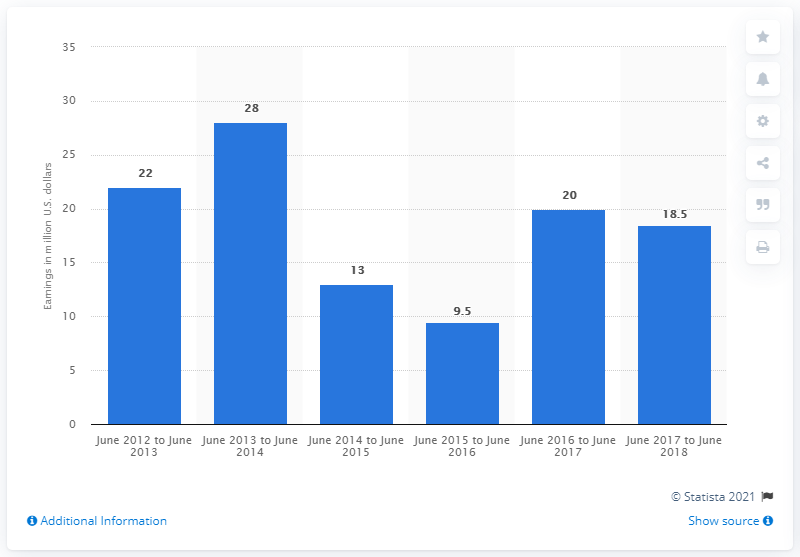Mention a couple of crucial points in this snapshot. What were Brown's earnings a year earlier? They were 20... Dan Brown earned approximately 18.5 million dollars between June 2017 and June 2018. 